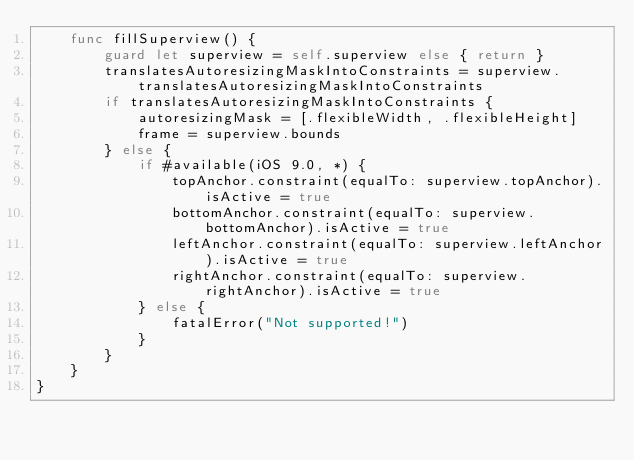<code> <loc_0><loc_0><loc_500><loc_500><_Swift_>    func fillSuperview() {
        guard let superview = self.superview else { return }
        translatesAutoresizingMaskIntoConstraints = superview.translatesAutoresizingMaskIntoConstraints
        if translatesAutoresizingMaskIntoConstraints {
            autoresizingMask = [.flexibleWidth, .flexibleHeight]
            frame = superview.bounds
        } else {
            if #available(iOS 9.0, *) {
                topAnchor.constraint(equalTo: superview.topAnchor).isActive = true
                bottomAnchor.constraint(equalTo: superview.bottomAnchor).isActive = true
                leftAnchor.constraint(equalTo: superview.leftAnchor).isActive = true
                rightAnchor.constraint(equalTo: superview.rightAnchor).isActive = true
            } else {
                fatalError("Not supported!")
            }
        }
    }
}
</code> 